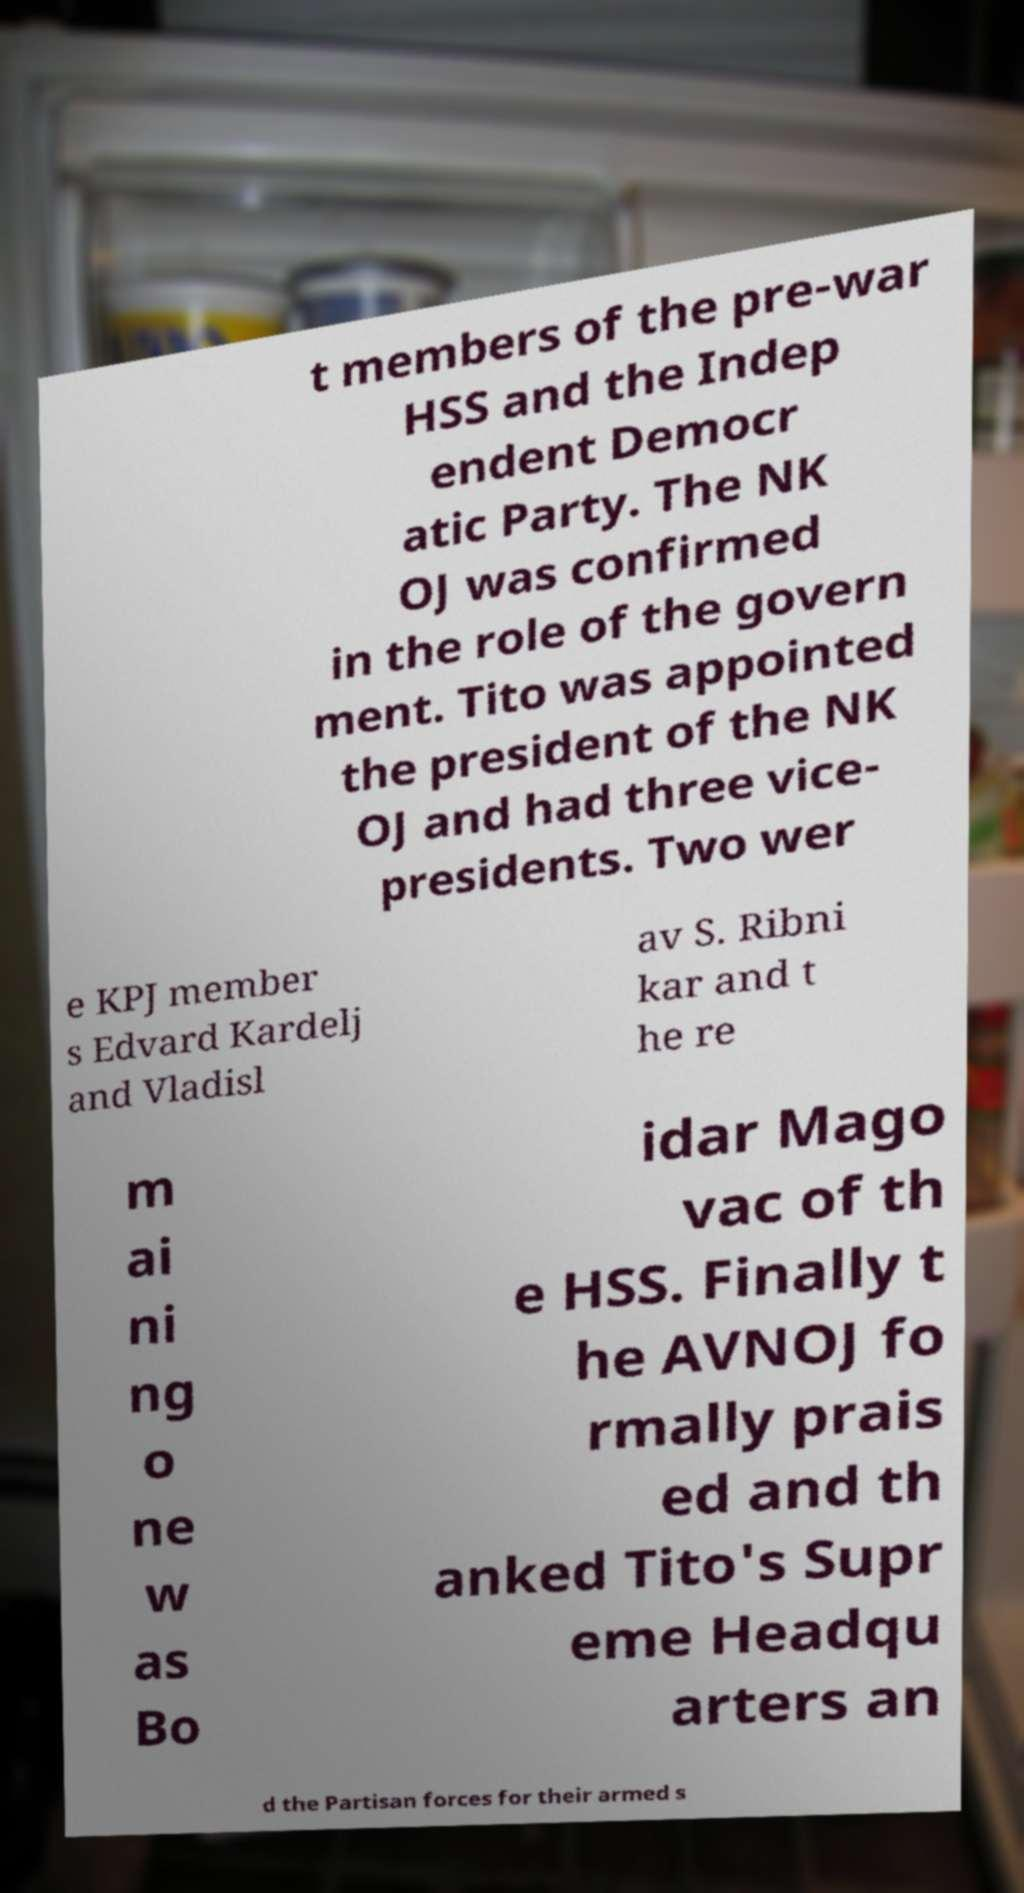For documentation purposes, I need the text within this image transcribed. Could you provide that? t members of the pre-war HSS and the Indep endent Democr atic Party. The NK OJ was confirmed in the role of the govern ment. Tito was appointed the president of the NK OJ and had three vice- presidents. Two wer e KPJ member s Edvard Kardelj and Vladisl av S. Ribni kar and t he re m ai ni ng o ne w as Bo idar Mago vac of th e HSS. Finally t he AVNOJ fo rmally prais ed and th anked Tito's Supr eme Headqu arters an d the Partisan forces for their armed s 